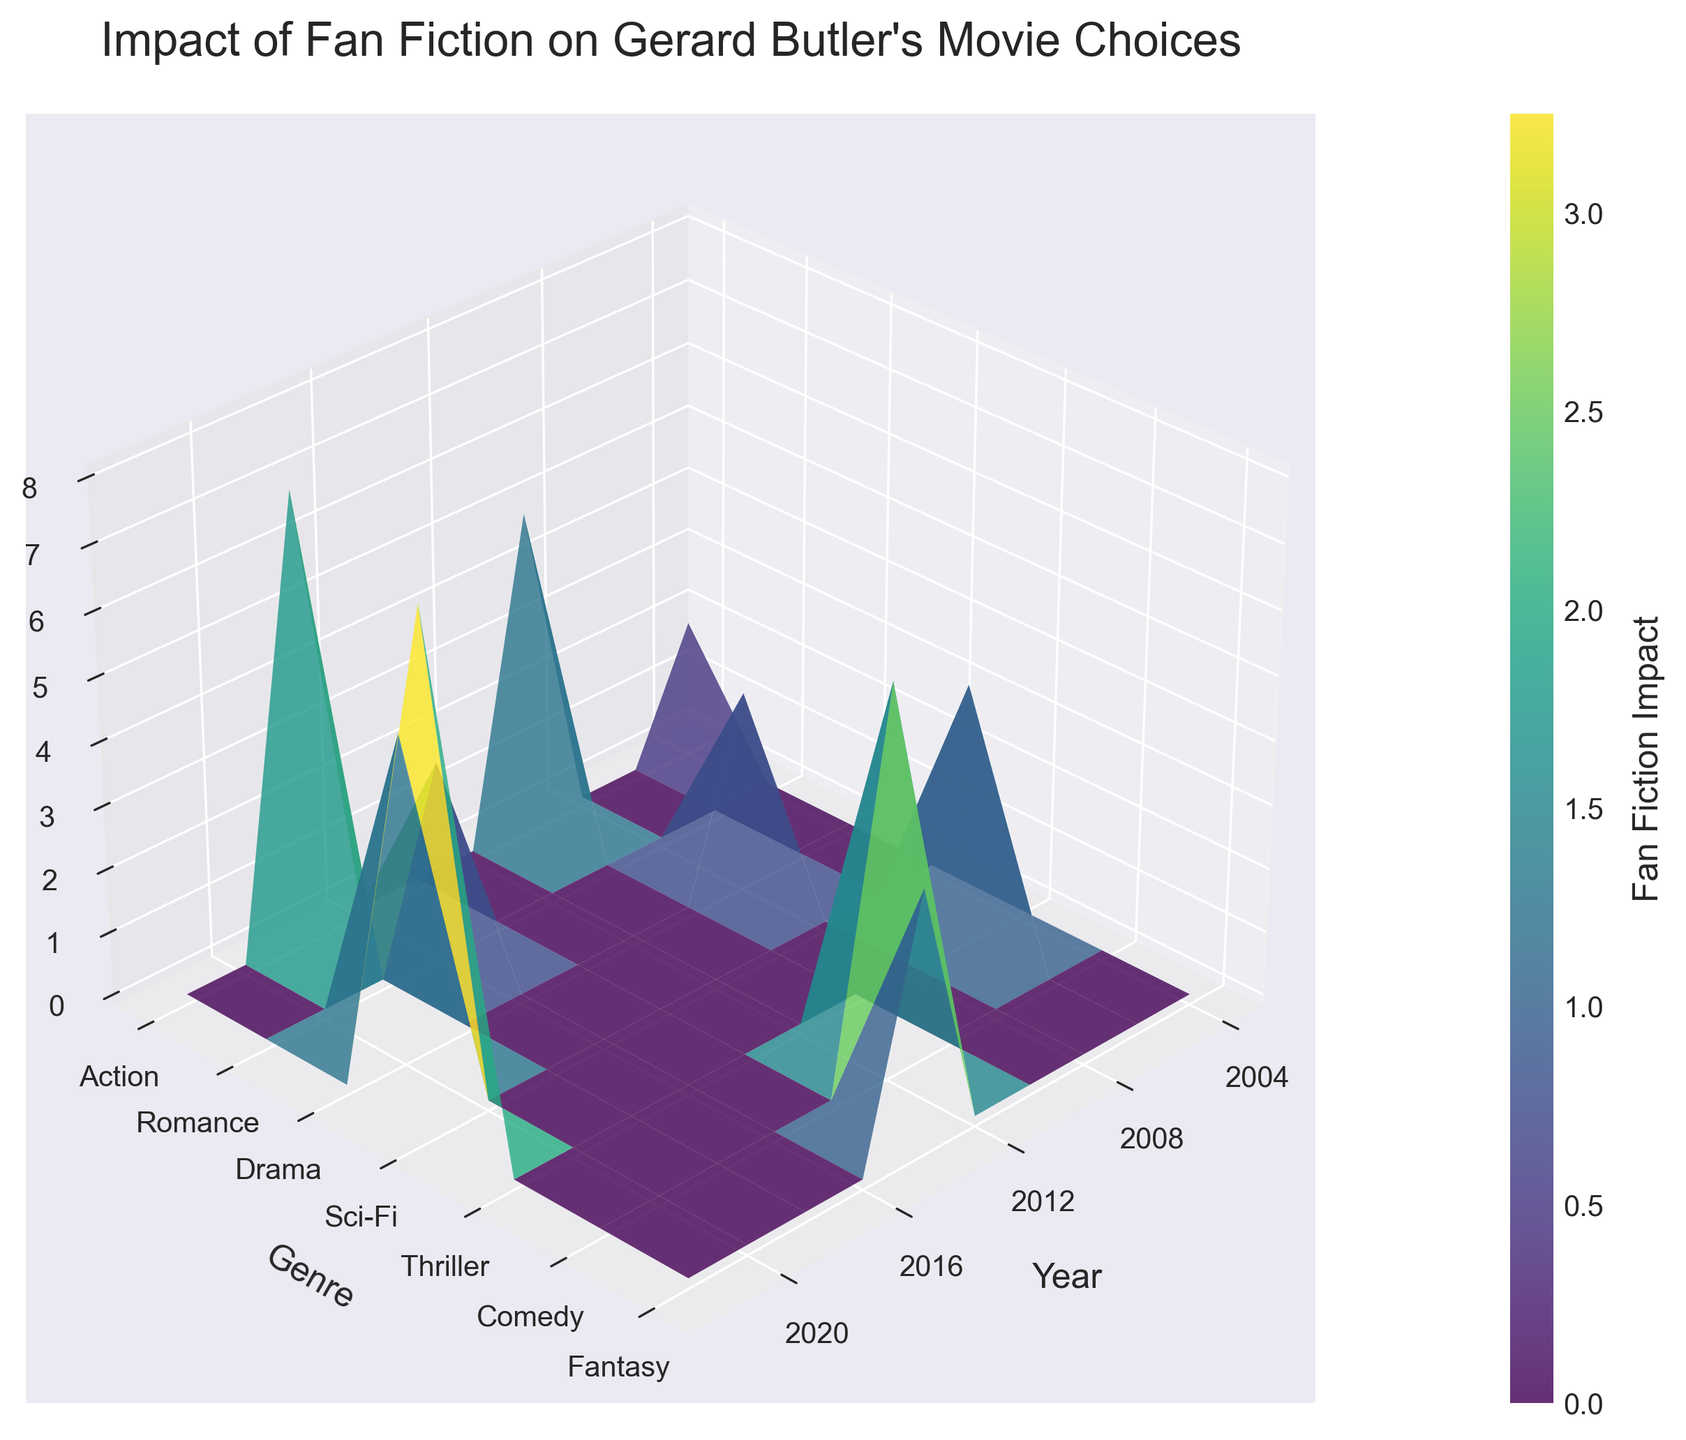What is the title of the plot? The title is written at the top of the plot. It says "Impact of Fan Fiction on Gerard Butler's Movie Choices".
Answer: Impact of Fan Fiction on Gerard Butler's Movie Choices Which genre has the highest Fan Fiction Impact in 2022? The impact values are visualized by the Z-axis. By locating 2022 on the X-axis and finding the corresponding value of the Z-axis for different genres, we see that Fantasy has the highest impact, depicted by the tallest peak.
Answer: Fantasy How does the Fan Fiction Impact of Action movies change from 2004 to 2020? From the Y-axis, identify the "Action" genre. Then follow the Z-axis values corresponding to the X-axis years 2004 to 2020: 2004 (2), 2010 (5), and 2018 (7). The Fan Fiction Impact increases over this period.
Answer: It increases Which year had the most significant Fan Fiction Impact on Sci-Fi movies? By locating Sci-Fi on the Y-axis and checking the corresponding Z-axis values for different years, it is noticeable that the peak in the Z-axis in the year 2012 indicates the highest impact for Sci-Fi movies.
Answer: 2012 Compare the Fan Fiction Impact on Drama movies between 2008 and 2020. Locate Drama on the Y-axis and check the Z-axis values for 2008 and 2020. The values are 3 for 2008 and 5 for 2020. The Fan Fiction Impact increased between these years.
Answer: It increased What is the average Fan Fiction Impact for Romance movies and Thriller movies over the observed years? Locate Romance and Thriller on the Y-axis and note their values from the Z-axis: Romance ([4]) and Thriller ([4]). Both have only one value each. So the average for each is calculated by summing their impacts and dividing by the number of data points. Average = (4 + 4) / 2.
Answer: 4 Which genre saw the highest increase in Fan Fiction Impact from 2010 to 2022? Identify the values on the Z-axis for both years per genre, then calculate the difference. Action (5 to 7), Sci-Fi (6 to 8), Drama (3 to 5). Sci-Fi shows the highest increase (2).
Answer: Sci-Fi How many genres are represented in the plot? By counting the unique labels along the Y-axis, we find the number of genres. Genres listed are Action, Romance, Drama, Sci-Fi, Thriller, Comedy, and Fantasy.
Answer: 7 In which year did Fan Fiction have the least impact on Gerard Butler’s movie choices? Observe the Z-axis values across all genres and years. The lowest value is 2, which corresponds to the year 2004 in the Action genre.
Answer: 2004 What is the visual trend in Fan Fiction Impact for movies over the years? Overall, by examining the peaks and troughs along the Z-axis over time along the X-axis, it appears that the Fan Fiction Impact has generally increased over the years across most genres.
Answer: Increasing trend 